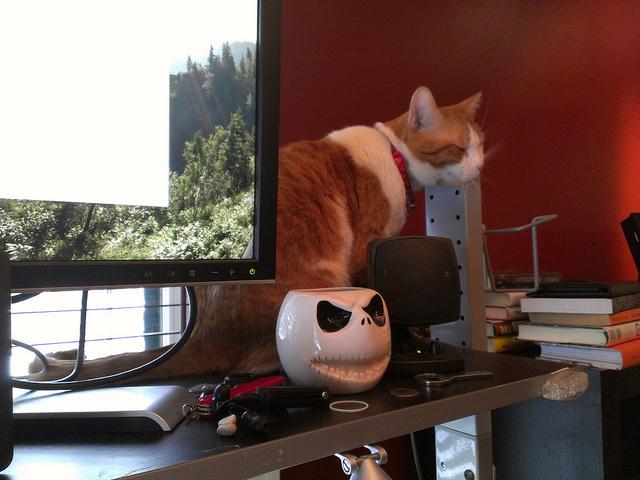What is the cat sitting on?
Concise answer only. Desk. Is that mug a character from a Tim Burton film?
Keep it brief. Yes. What is the coffee mug supposed to be?
Quick response, please. Jack skellington. 